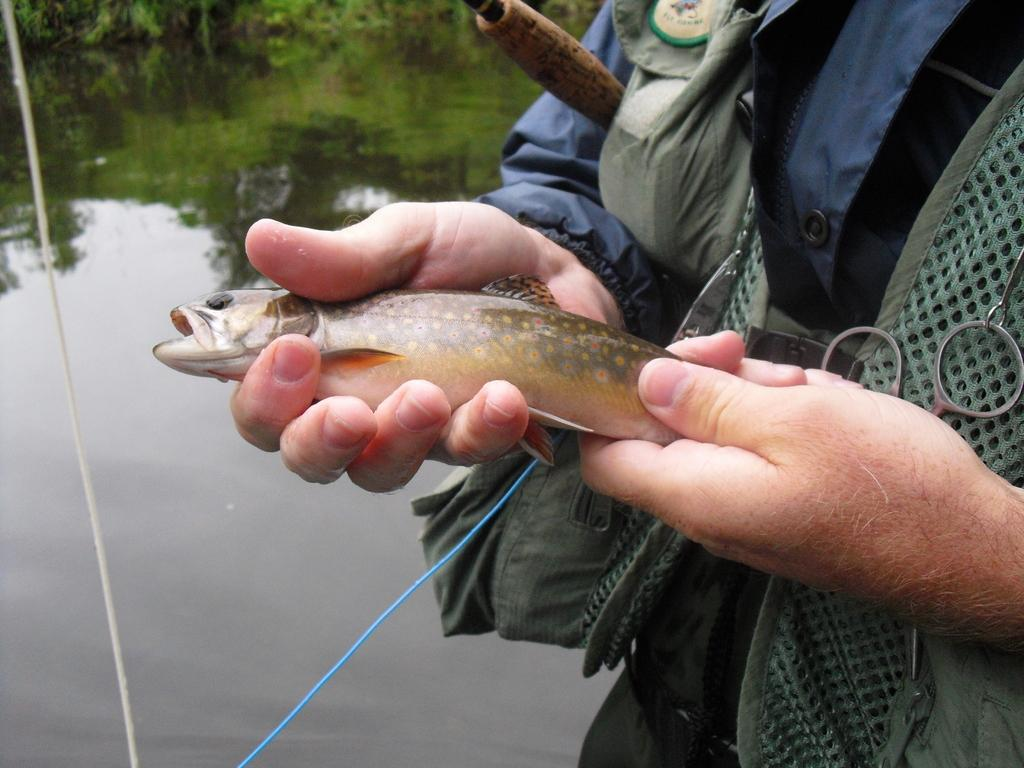Who or what is the main subject in the image? There is a person in the image. What is the person holding in the image? The person is holding a fish. Where is the fish located in the image? The fish is in the right corner of the image. What can be seen in the background of the image? There are trees and water visible in the background of the image. What type of voice can be heard coming from the calendar in the image? There is no calendar present in the image, and therefore no voice can be heard from it. 